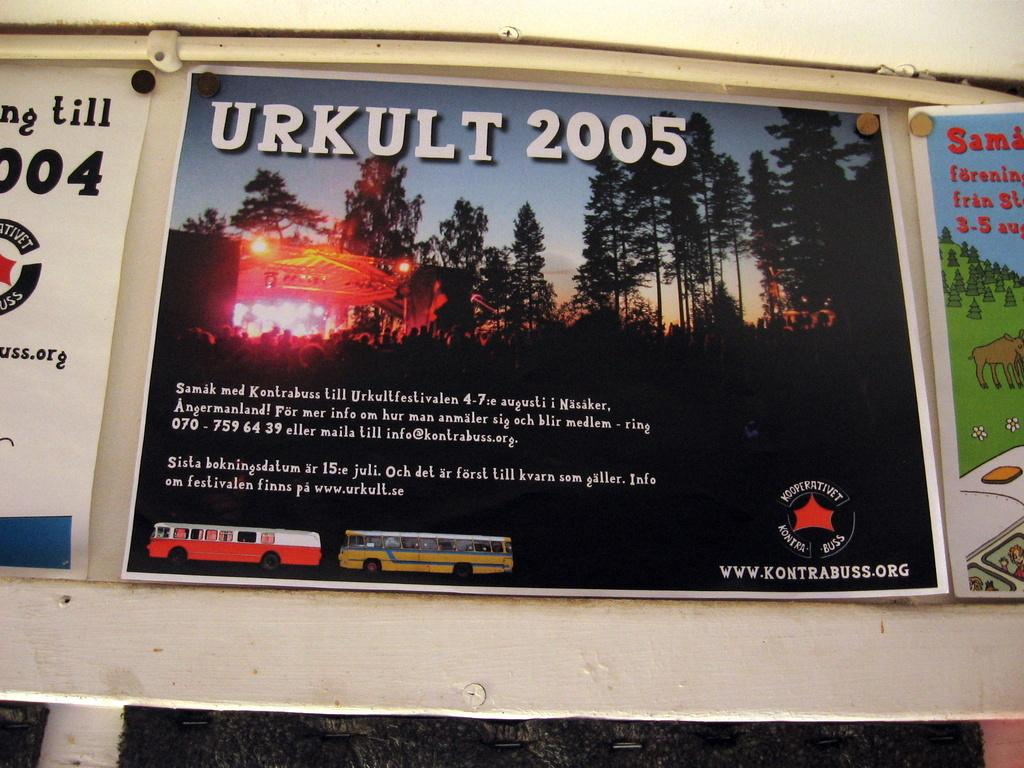<image>
Share a concise interpretation of the image provided. A sign that says Urkult 2005 with two buses on it. 